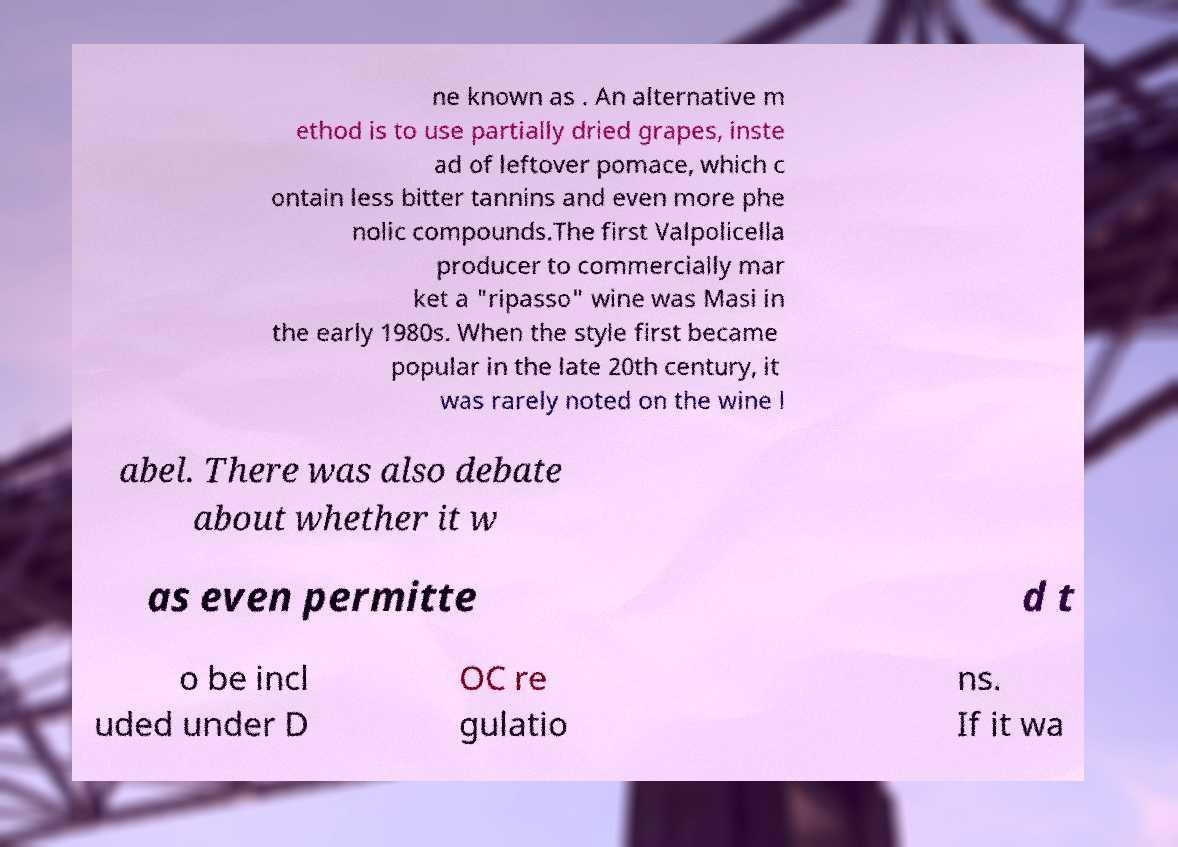For documentation purposes, I need the text within this image transcribed. Could you provide that? ne known as . An alternative m ethod is to use partially dried grapes, inste ad of leftover pomace, which c ontain less bitter tannins and even more phe nolic compounds.The first Valpolicella producer to commercially mar ket a "ripasso" wine was Masi in the early 1980s. When the style first became popular in the late 20th century, it was rarely noted on the wine l abel. There was also debate about whether it w as even permitte d t o be incl uded under D OC re gulatio ns. If it wa 